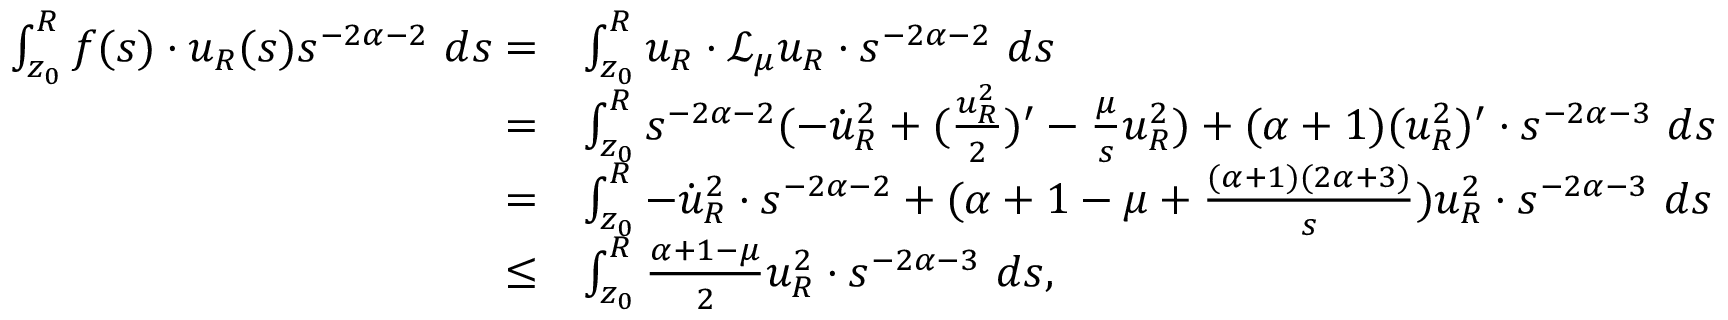<formula> <loc_0><loc_0><loc_500><loc_500>\begin{array} { r l } { \int _ { z _ { 0 } } ^ { R } f ( s ) \cdot u _ { R } ( s ) s ^ { - 2 \alpha - 2 } \ d s = } & { \int _ { z _ { 0 } } ^ { R } u _ { R } \cdot \mathcal { L } _ { \mu } u _ { R } \cdot s ^ { - 2 \alpha - 2 } \ d s } \\ { = } & { \int _ { z _ { 0 } } ^ { R } s ^ { - 2 \alpha - 2 } ( - \dot { u } _ { R } ^ { 2 } + ( \frac { u _ { R } ^ { 2 } } { 2 } ) ^ { \prime } - \frac { \mu } { s } u _ { R } ^ { 2 } ) + ( \alpha + 1 ) ( u _ { R } ^ { 2 } ) ^ { \prime } \cdot s ^ { - 2 \alpha - 3 } \ d s } \\ { = } & { \int _ { z _ { 0 } } ^ { R } - \dot { u } _ { R } ^ { 2 } \cdot s ^ { - 2 \alpha - 2 } + ( \alpha + 1 - \mu + \frac { ( \alpha + 1 ) ( 2 \alpha + 3 ) } { s } ) u _ { R } ^ { 2 } \cdot s ^ { - 2 \alpha - 3 } \ d s } \\ { \leq } & { \int _ { z _ { 0 } } ^ { R } \frac { \alpha + 1 - \mu } { 2 } u _ { R } ^ { 2 } \cdot s ^ { - 2 \alpha - 3 } \ d s , } \end{array}</formula> 